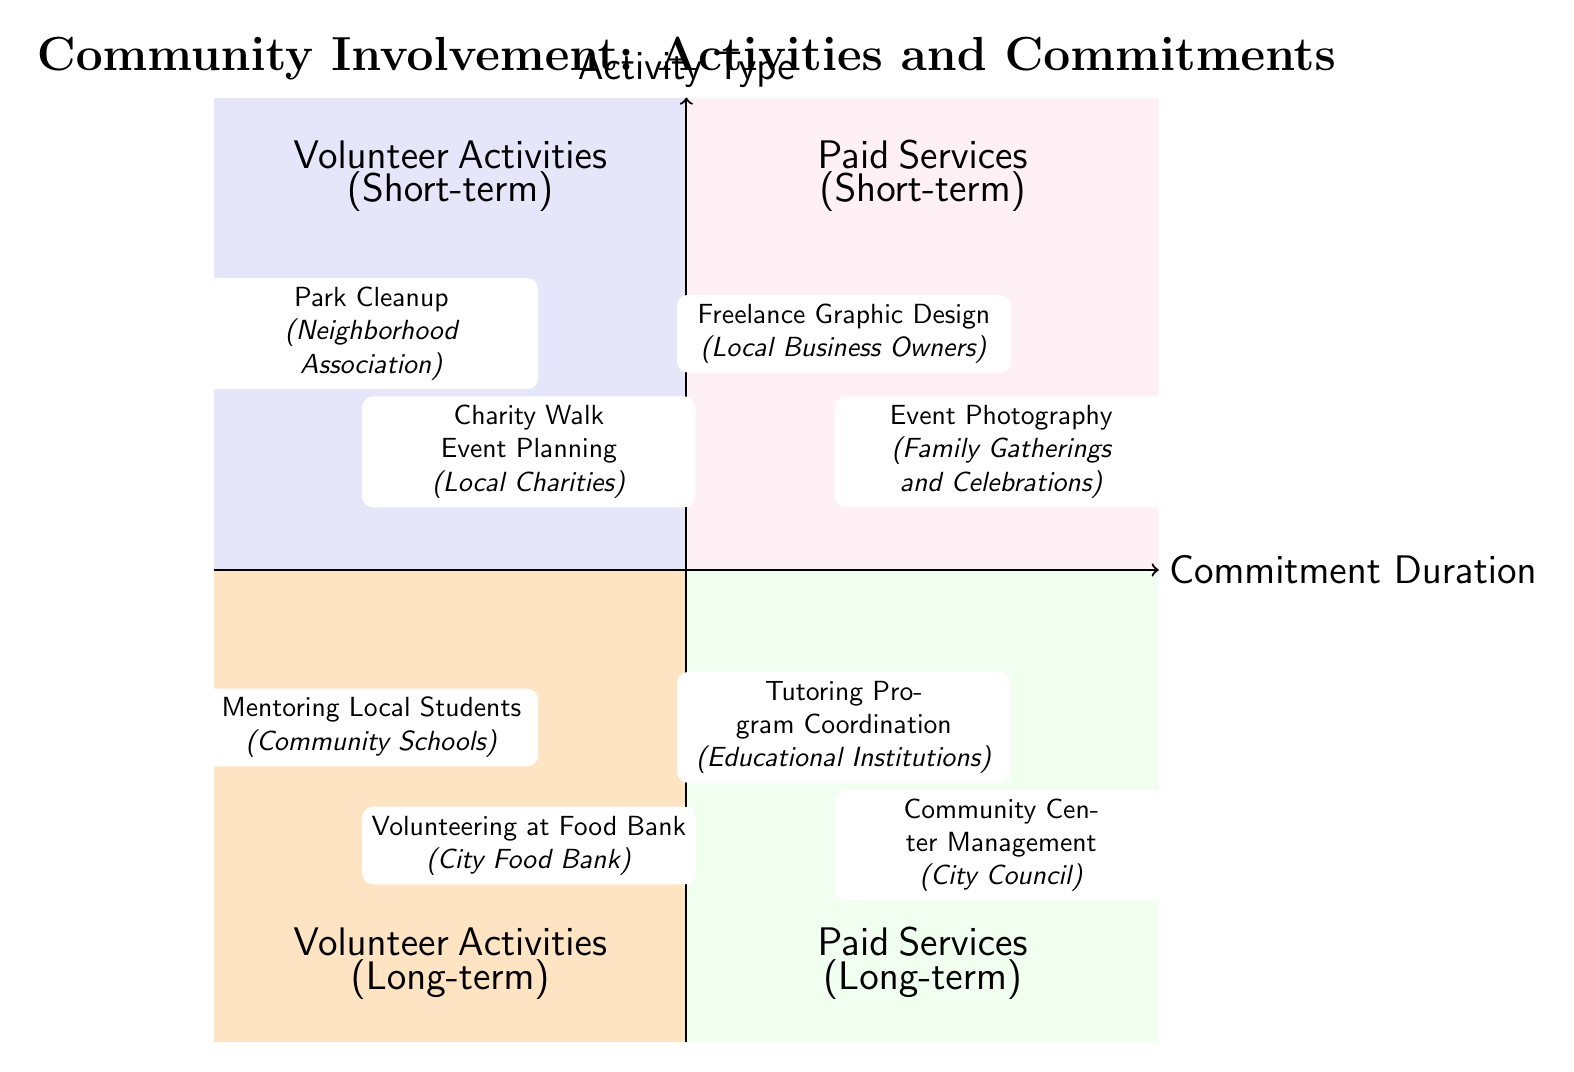What activities are in the Volunteer Activities (Short-term) quadrant? The Volunteer Activities (Short-term) quadrant includes activities such as Park Cleanup and Charity Walk Event Planning, which are specifically noted in this section of the diagram.
Answer: Park Cleanup, Charity Walk Event Planning How many activities are listed under Paid Services (Long-term)? The Paid Services (Long-term) quadrant contains two activities: Tutoring Program Coordination and Community Center Management, thus the total number of activities is counted as two.
Answer: 2 Which activity involves Local Business Owners? The Paid Services (Short-term) quadrant includes the activity Freelance Graphic Design, which specifically mentions Local Business Owners as the entity associated with this activity.
Answer: Freelance Graphic Design What is the connection between Volunteer Activities and Long-term Commitments? Two activities are represented in the Volunteer Activities (Long-term) quadrant: Mentoring Local Students and Volunteering at Food Bank, showing the type of commitment these activities have.
Answer: Mentoring Local Students, Volunteering at Food Bank Which quadrant contains Community Center Management? Community Center Management is listed in the Paid Services (Long-term) quadrant according to the layout of the diagram, which assigns this activity to that specific quadrant.
Answer: Paid Services (Long-term) Which quadrant has more activities, Volunteer Activities or Paid Services? By counting the activities in each quadrant, we find Volunteer Activities has four (two short-term and two long-term), while Paid Services has four as well (two short-term and two long-term), leading to the conclusion both quadrants have the same number of activities.
Answer: Equal What type of entity is associated with the Park Cleanup activity? The activity Park Cleanup is associated with the Neighborhood Association, as indicated in the diagram where the short-term activity is noted.
Answer: Neighborhood Association Which activity has a connection to Educational Institutions? Tutoring Program Coordination, found in the Paid Services (Long-term) quadrant, is specifically connected to Educational Institutions as per the information displayed in the diagram.
Answer: Tutoring Program Coordination What distinguishes activities in the Paid Services quadrant compared to the Volunteer Activities quadrant? The Paid Services quadrant consists of activities that are compensated, while the Volunteer Activities quadrant contains unpaid activities. This distinction is fundamental based on the categorization of each quadrant in the diagram.
Answer: Compensated vs. Unpaid Activities 